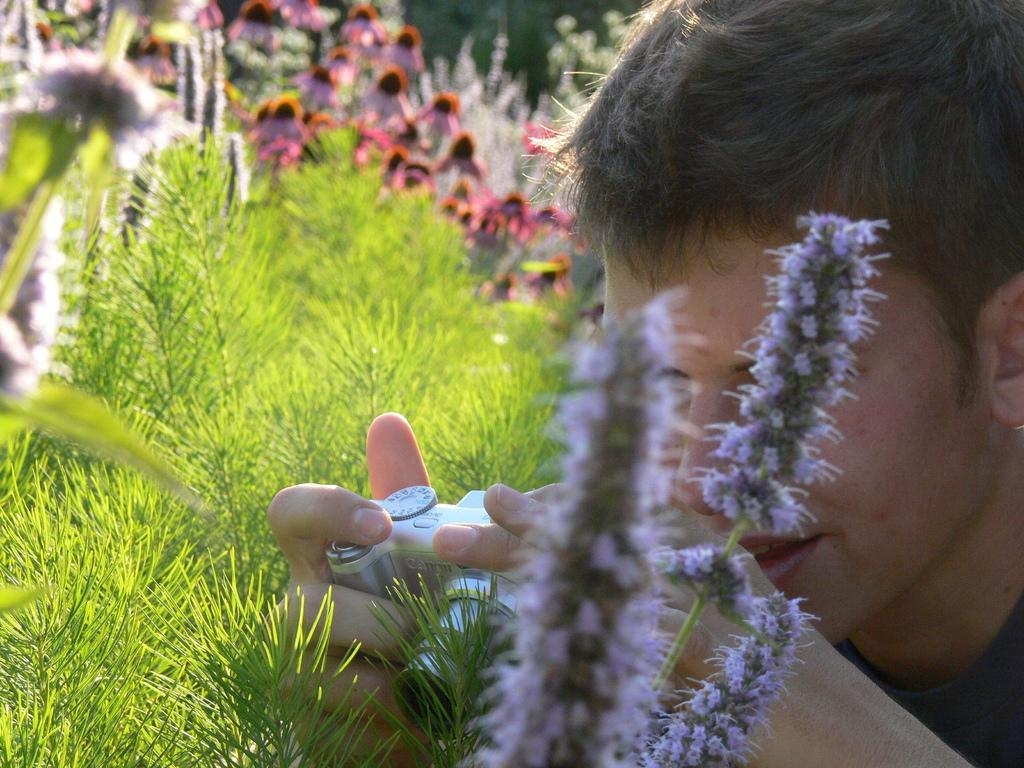What type of plants can be seen in the image? There are flowers in the image. What type of vegetation is present in the image besides flowers? There is grass in the image. Where is the man located in the image? The man is on the right side of the image. What is the man holding in the image? The man is holding a camera. What type of play is the man participating in with the flowers in the image? There is no play or interaction between the man and the flowers in the image; he is simply holding a camera. Can you compare the size of the flowers to the size of the man in the image? The size of the flowers and the man cannot be compared in the image, as there is no reference point or scale provided. 